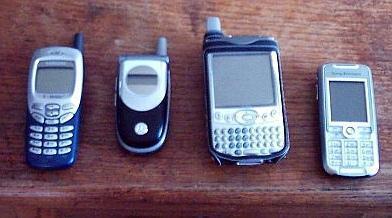How many are iPhones?
Give a very brief answer. 0. How many cell phones are there?
Give a very brief answer. 4. 